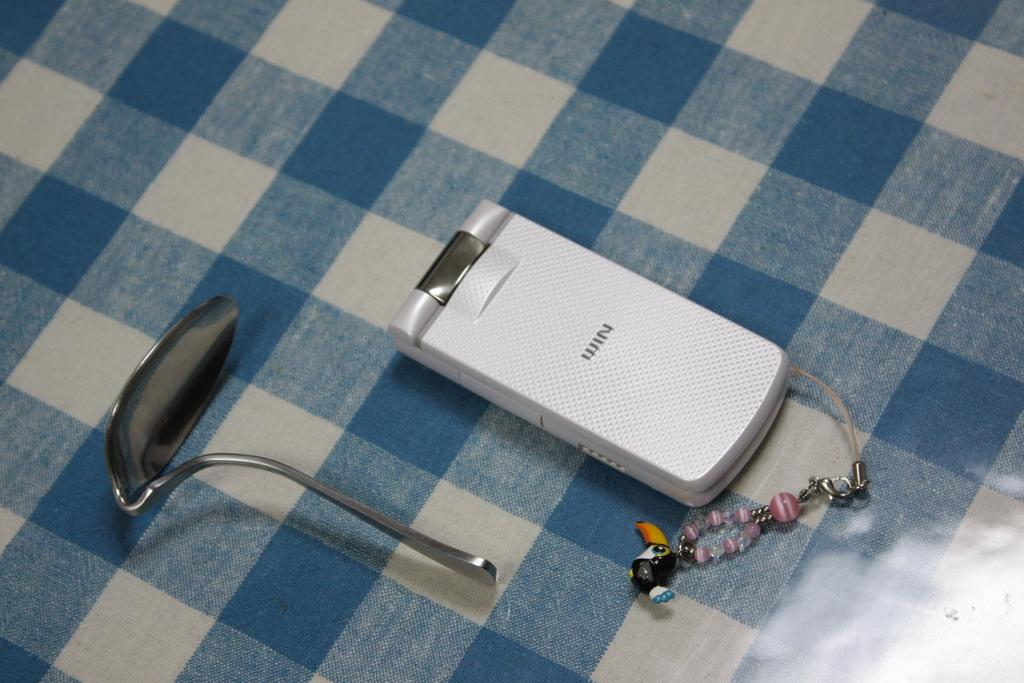<image>
Offer a succinct explanation of the picture presented. A white WIN flip phone is on a blue and white checkered table next to a bent spoon. 